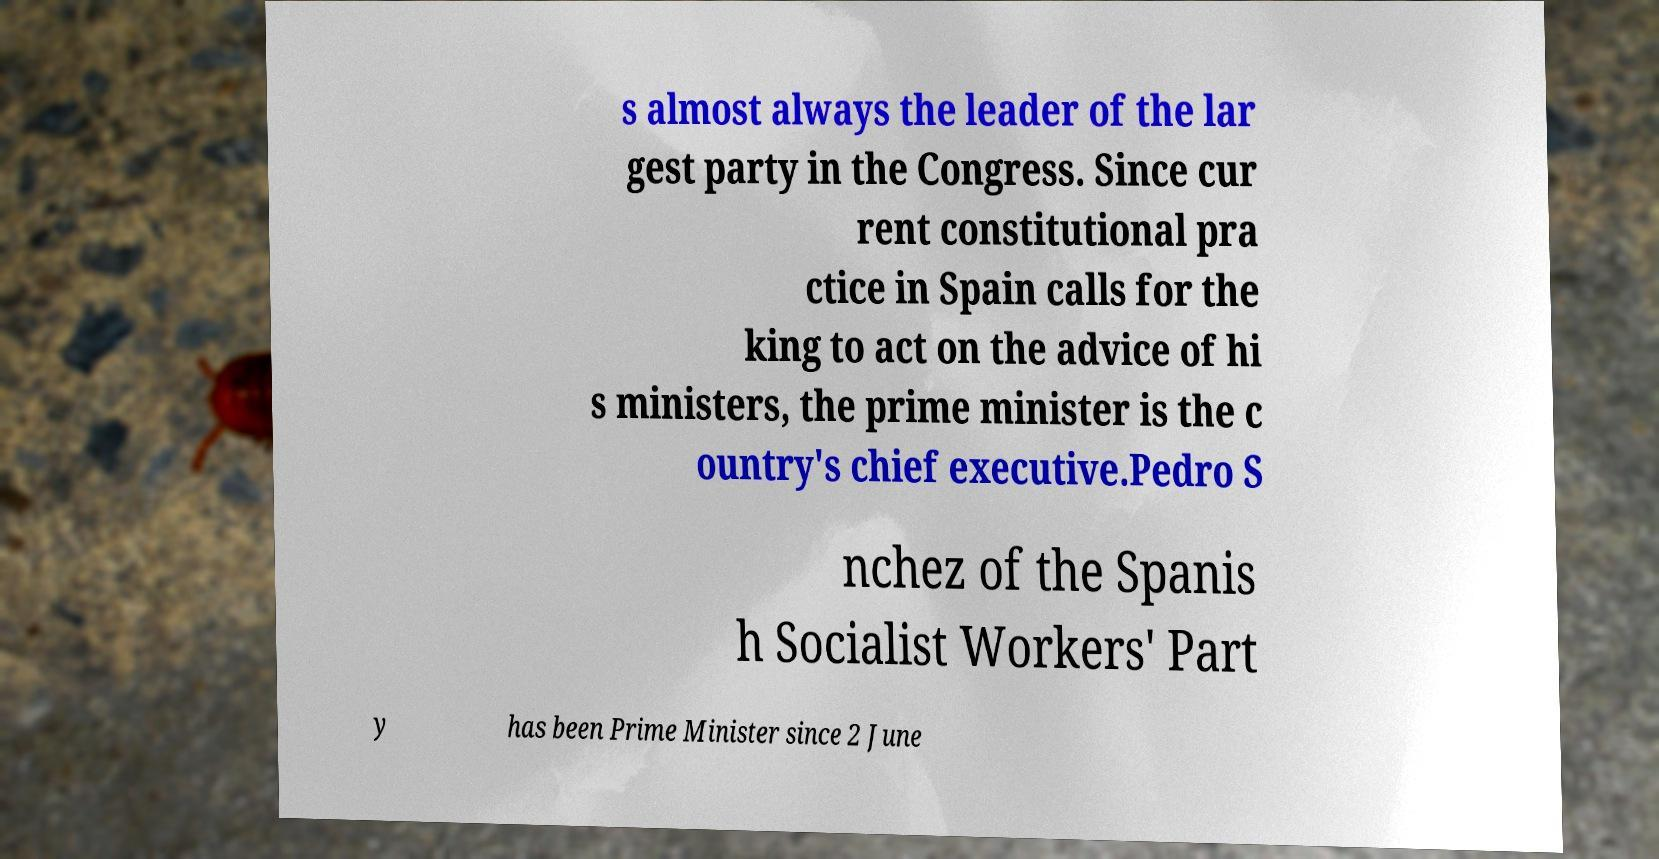Can you accurately transcribe the text from the provided image for me? s almost always the leader of the lar gest party in the Congress. Since cur rent constitutional pra ctice in Spain calls for the king to act on the advice of hi s ministers, the prime minister is the c ountry's chief executive.Pedro S nchez of the Spanis h Socialist Workers' Part y has been Prime Minister since 2 June 